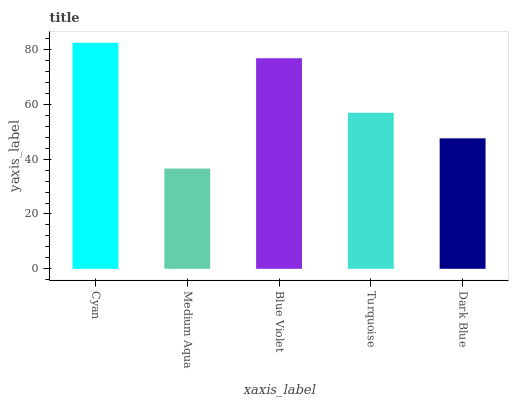Is Medium Aqua the minimum?
Answer yes or no. Yes. Is Cyan the maximum?
Answer yes or no. Yes. Is Blue Violet the minimum?
Answer yes or no. No. Is Blue Violet the maximum?
Answer yes or no. No. Is Blue Violet greater than Medium Aqua?
Answer yes or no. Yes. Is Medium Aqua less than Blue Violet?
Answer yes or no. Yes. Is Medium Aqua greater than Blue Violet?
Answer yes or no. No. Is Blue Violet less than Medium Aqua?
Answer yes or no. No. Is Turquoise the high median?
Answer yes or no. Yes. Is Turquoise the low median?
Answer yes or no. Yes. Is Blue Violet the high median?
Answer yes or no. No. Is Blue Violet the low median?
Answer yes or no. No. 